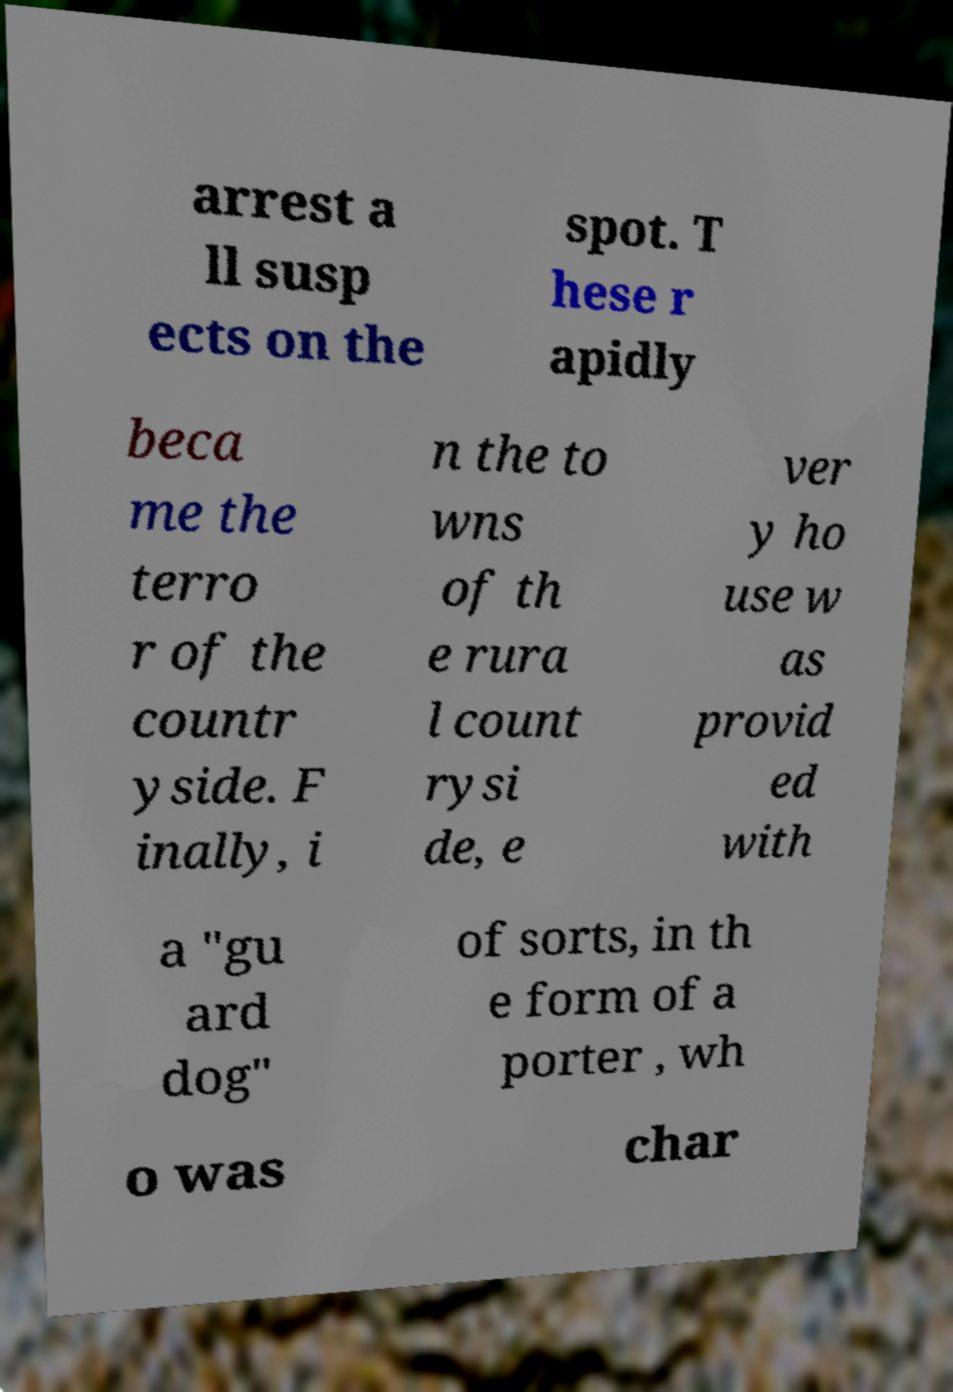What messages or text are displayed in this image? I need them in a readable, typed format. arrest a ll susp ects on the spot. T hese r apidly beca me the terro r of the countr yside. F inally, i n the to wns of th e rura l count rysi de, e ver y ho use w as provid ed with a "gu ard dog" of sorts, in th e form of a porter , wh o was char 